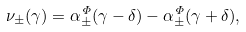Convert formula to latex. <formula><loc_0><loc_0><loc_500><loc_500>\nu _ { \pm } ( \gamma ) = \alpha _ { \pm } ^ { \Phi } ( \gamma - \delta ) - \alpha _ { \pm } ^ { \Phi } ( \gamma + \delta ) ,</formula> 